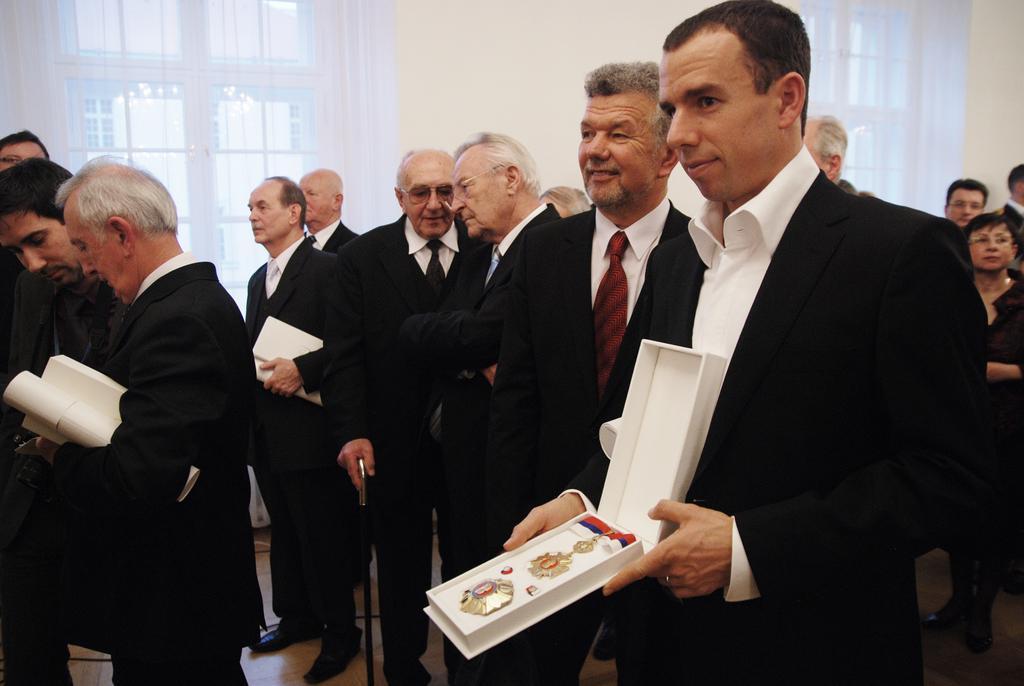How would you summarize this image in a sentence or two? In this image there are group of people in the middle who are wearing the suits. On the right side there is a person who opened the box with his hands. In the box it looks like a medal. In the background there are windows beside the wall. On the left side there is another person who is holding the box and a paper. 